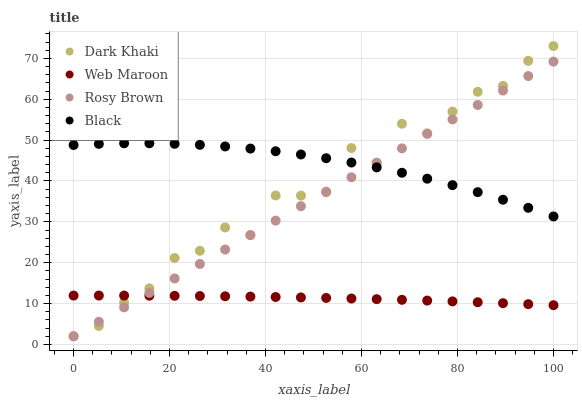Does Web Maroon have the minimum area under the curve?
Answer yes or no. Yes. Does Black have the maximum area under the curve?
Answer yes or no. Yes. Does Rosy Brown have the minimum area under the curve?
Answer yes or no. No. Does Rosy Brown have the maximum area under the curve?
Answer yes or no. No. Is Rosy Brown the smoothest?
Answer yes or no. Yes. Is Dark Khaki the roughest?
Answer yes or no. Yes. Is Black the smoothest?
Answer yes or no. No. Is Black the roughest?
Answer yes or no. No. Does Dark Khaki have the lowest value?
Answer yes or no. Yes. Does Black have the lowest value?
Answer yes or no. No. Does Dark Khaki have the highest value?
Answer yes or no. Yes. Does Black have the highest value?
Answer yes or no. No. Is Web Maroon less than Black?
Answer yes or no. Yes. Is Black greater than Web Maroon?
Answer yes or no. Yes. Does Dark Khaki intersect Web Maroon?
Answer yes or no. Yes. Is Dark Khaki less than Web Maroon?
Answer yes or no. No. Is Dark Khaki greater than Web Maroon?
Answer yes or no. No. Does Web Maroon intersect Black?
Answer yes or no. No. 